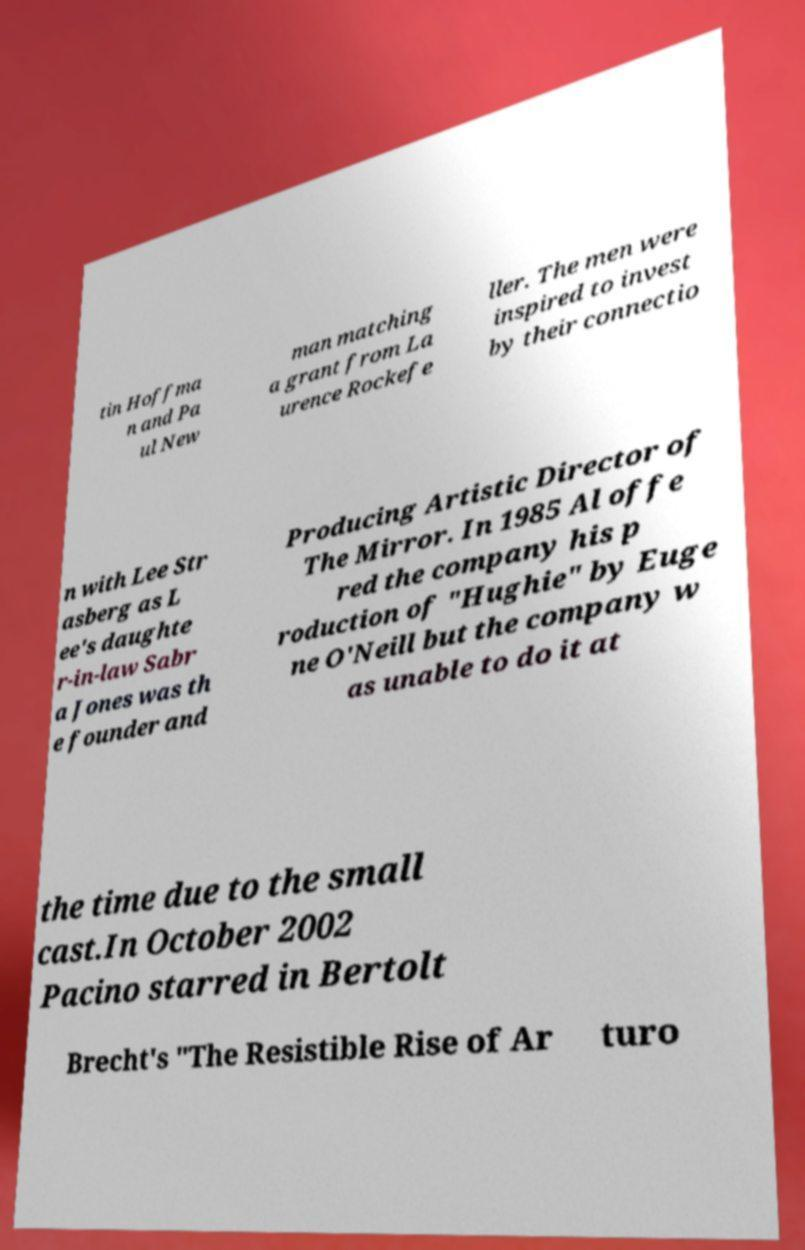Could you extract and type out the text from this image? tin Hoffma n and Pa ul New man matching a grant from La urence Rockefe ller. The men were inspired to invest by their connectio n with Lee Str asberg as L ee's daughte r-in-law Sabr a Jones was th e founder and Producing Artistic Director of The Mirror. In 1985 Al offe red the company his p roduction of "Hughie" by Euge ne O'Neill but the company w as unable to do it at the time due to the small cast.In October 2002 Pacino starred in Bertolt Brecht's "The Resistible Rise of Ar turo 